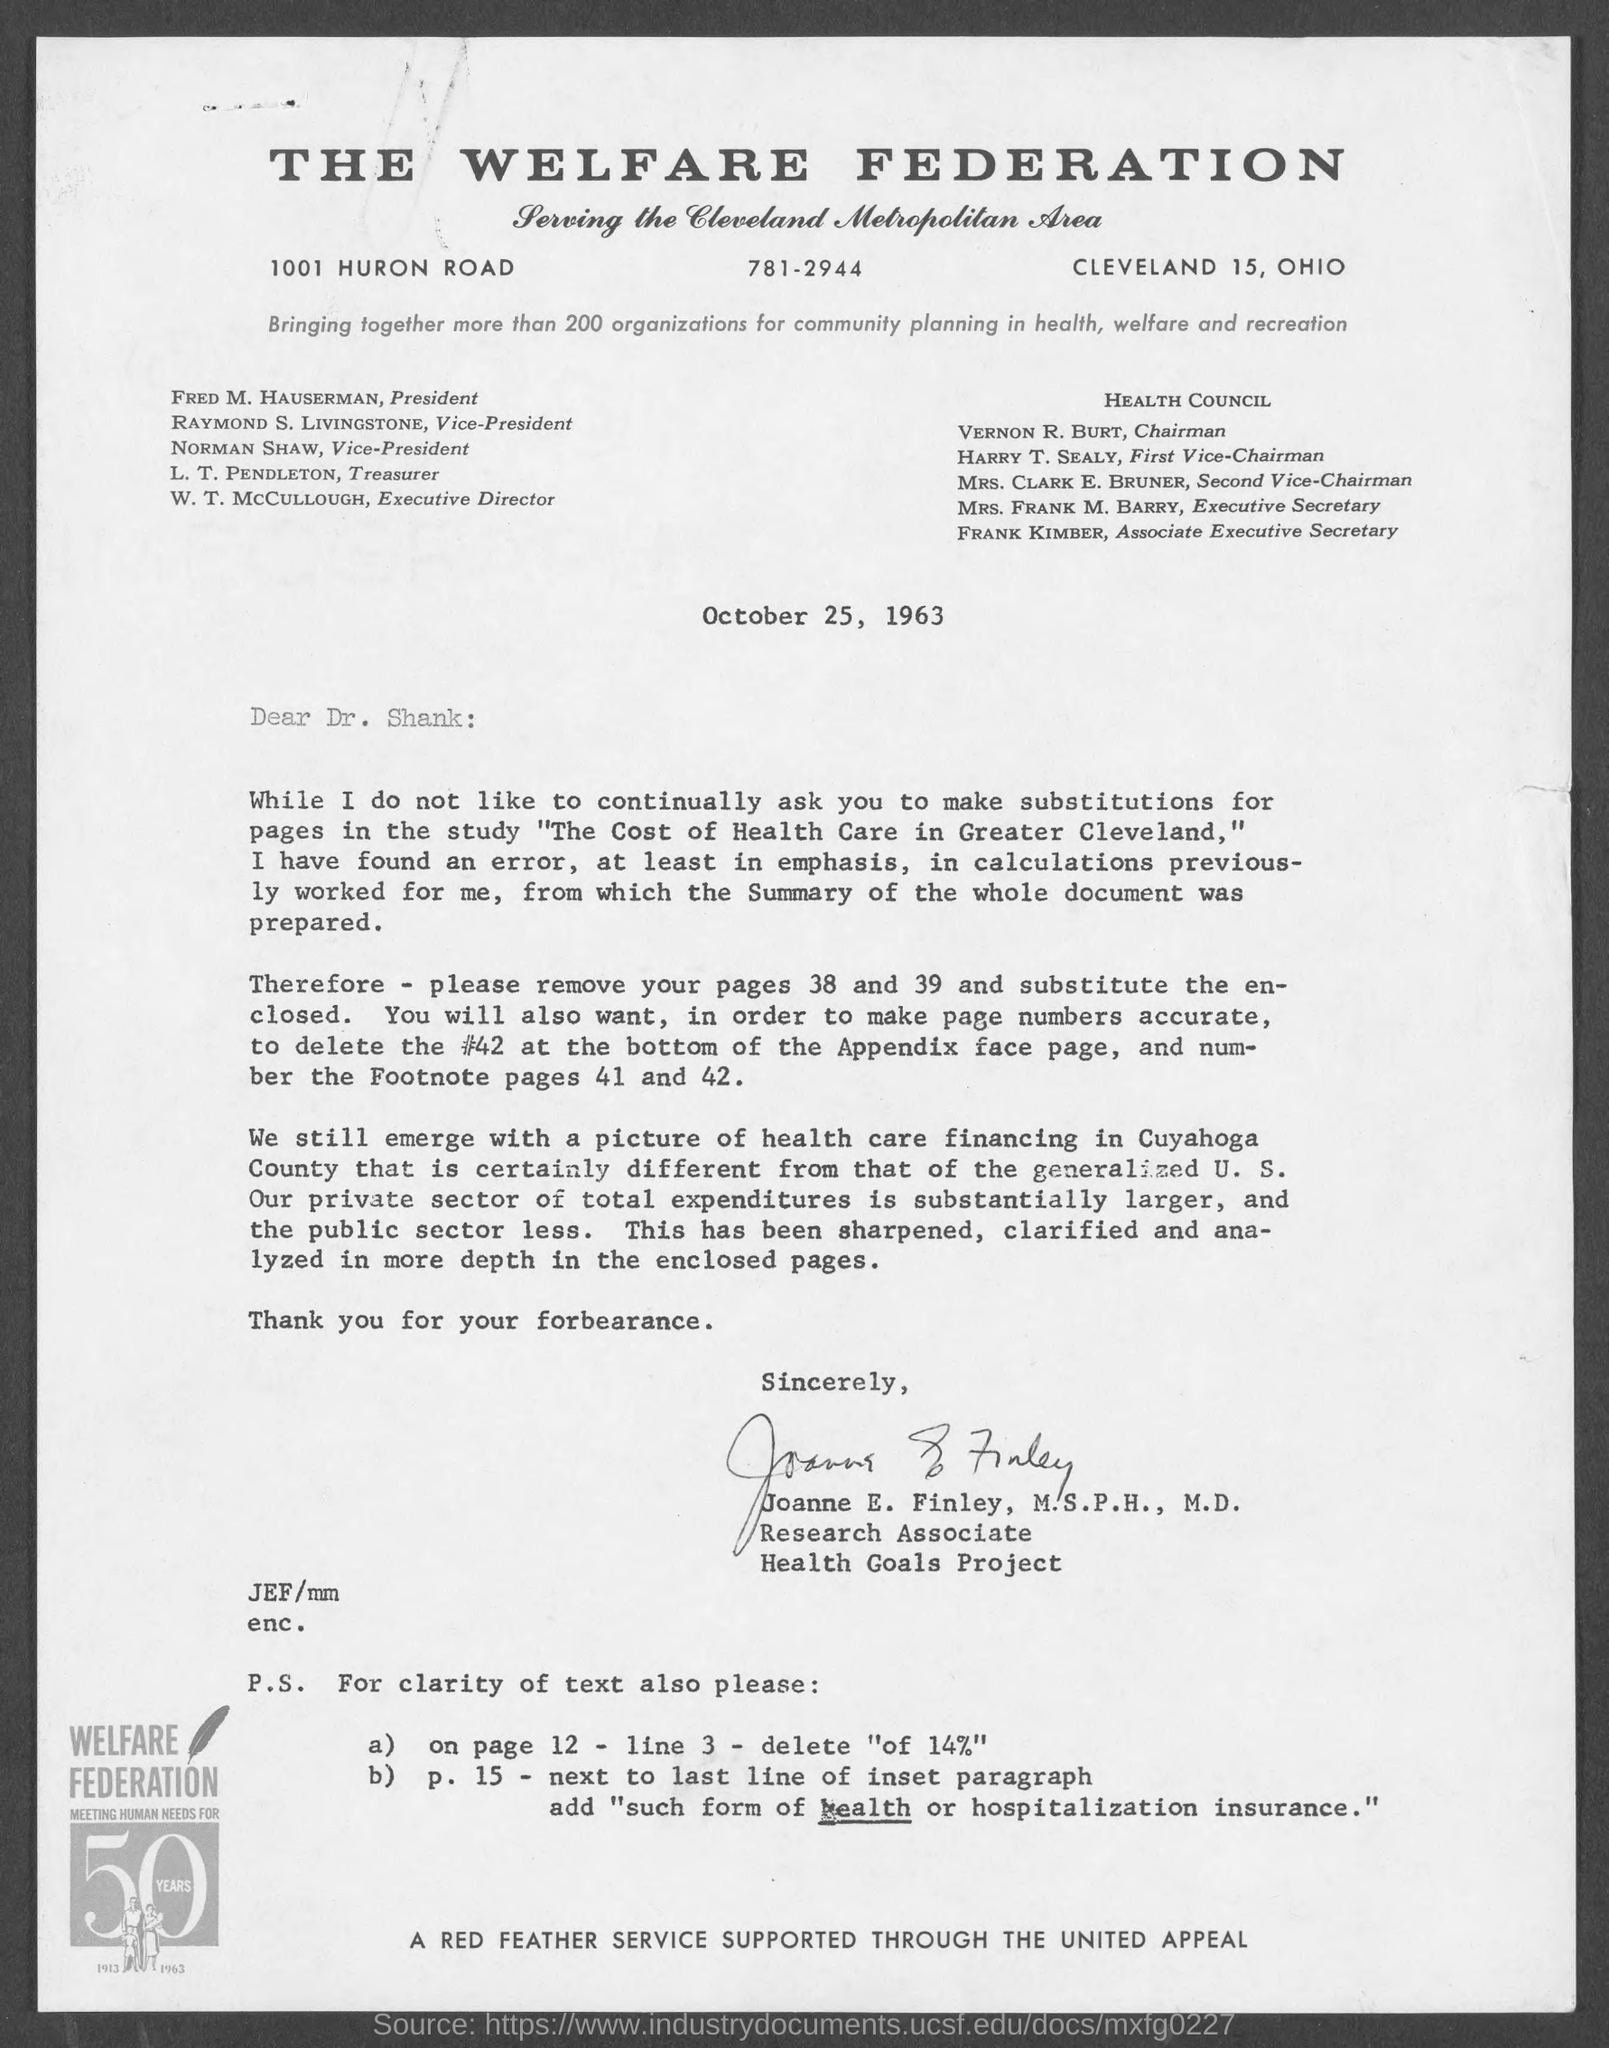What is the Title of the document?
Ensure brevity in your answer.  The Welfare Federation. What is the date on the document?
Your response must be concise. October 25, 1963. To Whom is this letter addressed to?
Provide a short and direct response. Dr. Shank. Who is this letter from?
Your answer should be very brief. Joanne E. Finley, M.S.P.H., M.D. 